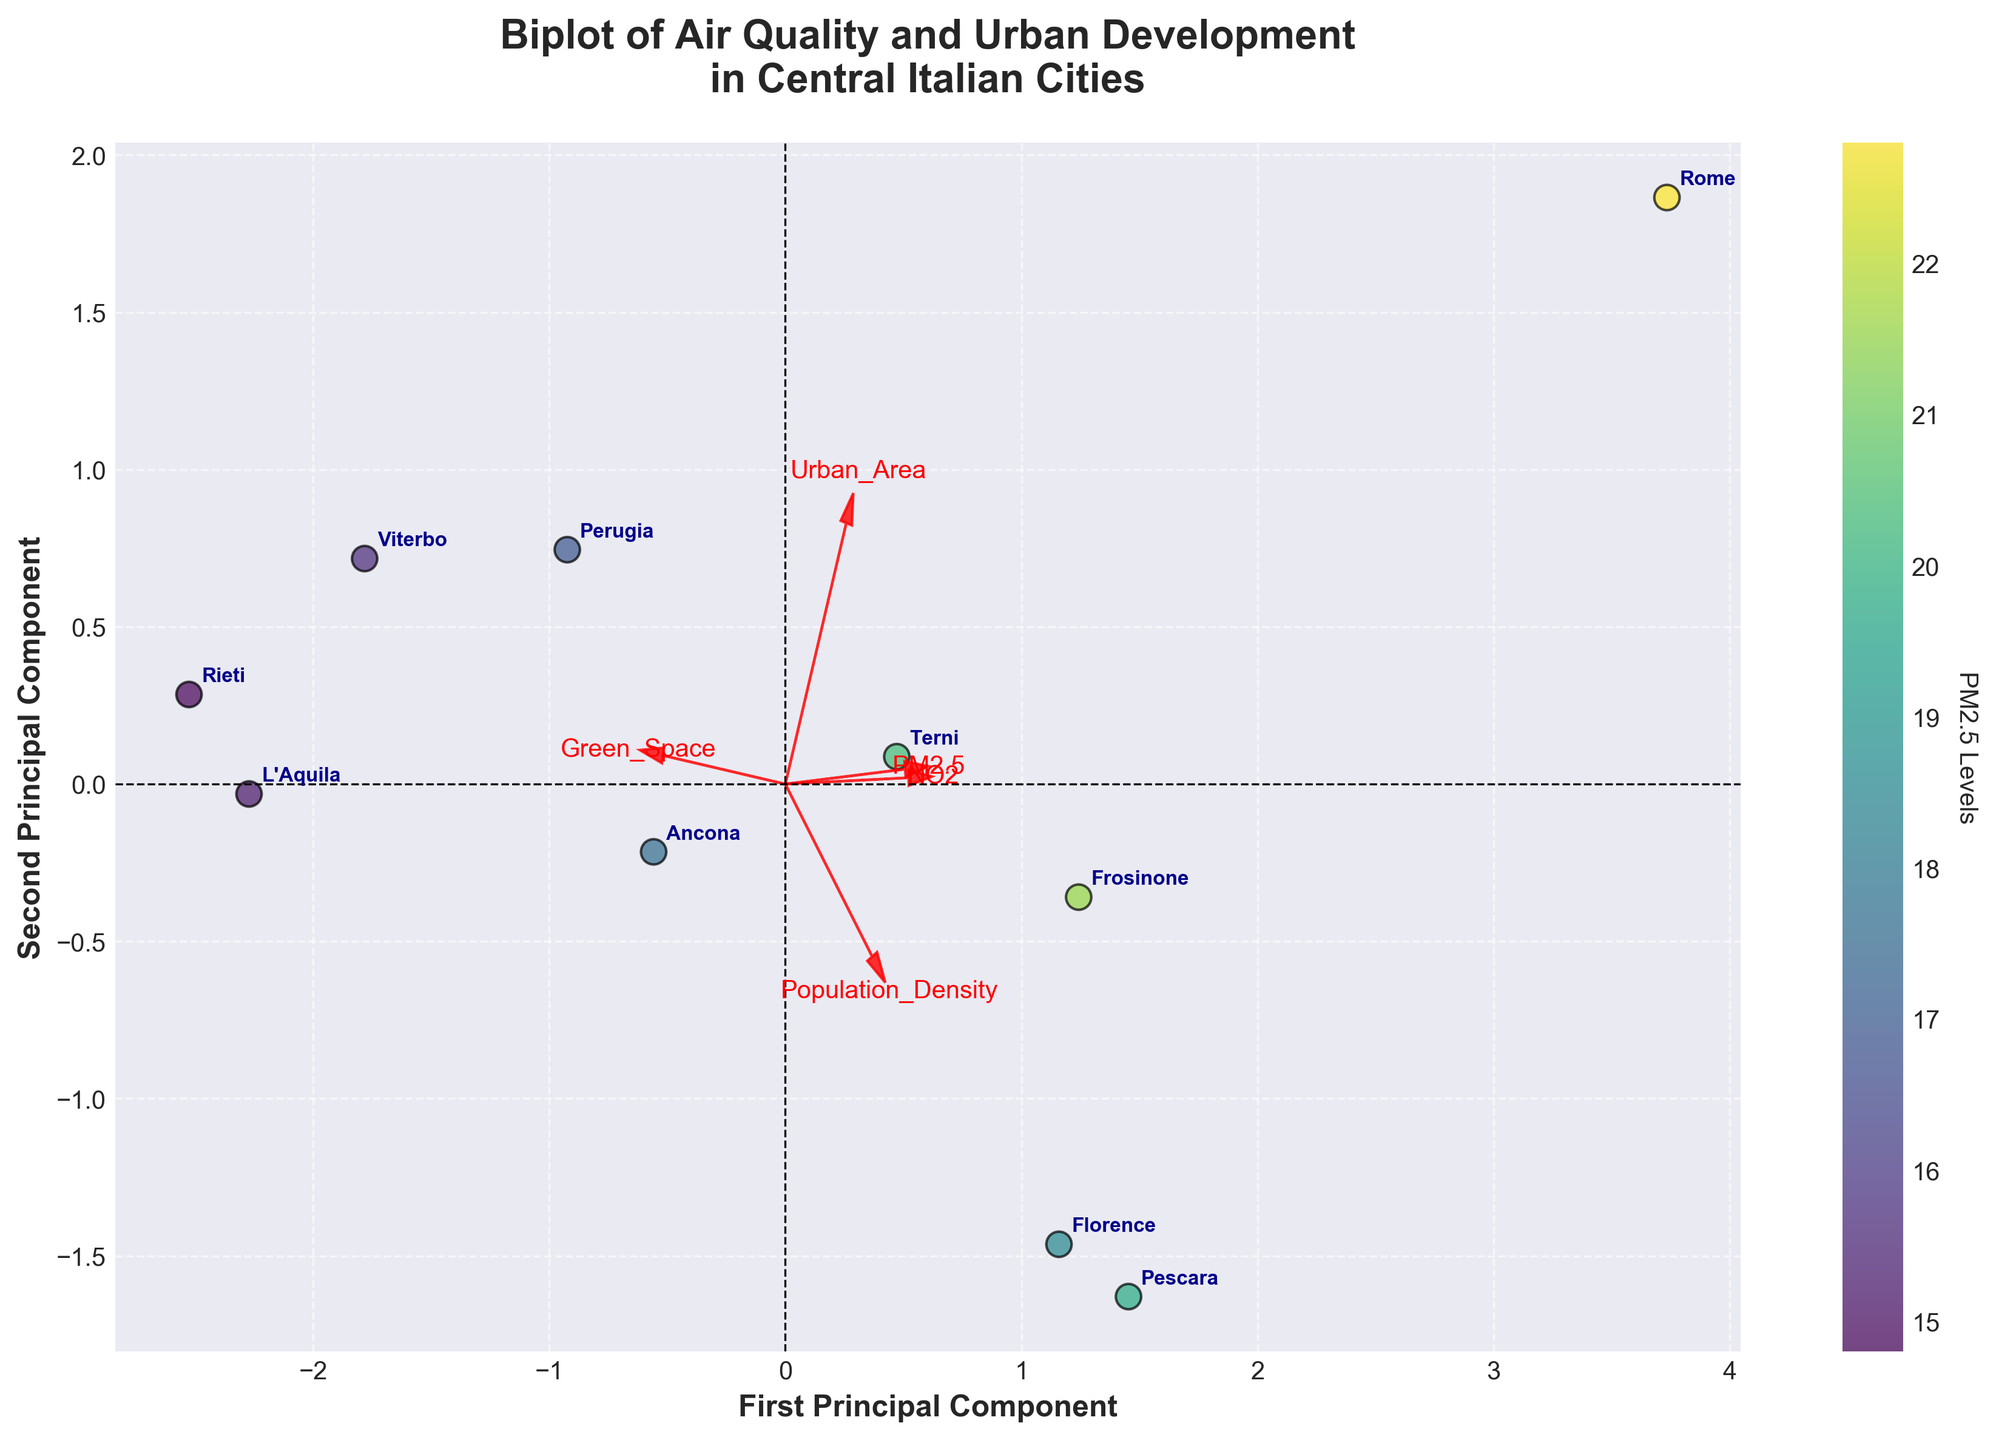Which city has the highest PM2.5 levels based on the biplot? The biplot shows data points colored by PM2.5 levels. By looking for the darkest shade (corresponding to the highest level of PM2.5), we can identify the city.
Answer: Rome Which city is associated with the highest value along the first principal component? The city with the farthest reach to the right along the x-axis of the biplot represents the highest value along the first principal component.
Answer: Rome Which parameter shows the longest feature vector on the biplot? Feature vectors are the red arrows in the biplot. The parameter with the longest arrow represents the parameter with the highest variance along the principal components.
Answer: Urban_Area How do L'Aquila and Frosinone compare in terms of PM2.5 levels? By looking at the color gradient of the data points for L'Aquila and Frosinone, we can compare their shades, which indicate PM2.5 levels.
Answer: L'Aquila has lower PM2.5 levels than Frosinone Which city has the lowest NO2 levels according to the biplot? By examining the scatter plot and observing the data points corresponding to NO2 along the corresponding feature vector, we can identify the city with the lowest value.
Answer: Rieti What direction does the 'Green_Space' vector point, and what does it imply? The direction of the 'Green_Space' vector can be observed in the biplot. It indicates the correlation of green space to the two principal components.
Answer: It points up and to the right, implying a positive correlation with both principal components If the 'Population_Density' vector is pointing in a certain direction, which city is furthest along its axis? By following the direction of the 'Population_Density' vector and finding the data point furthest along this vector, we can identify the city.
Answer: Pescara Which city lies closest to the origin of the biplot? The city located closest to the point (0,0) on the biplot is the one with values most similar to the mean of all parameters after standardization.
Answer: Viterbo Compare Ancona and Terni in terms of their positions along the second principal component. By observing their locations along the y-axis, we can see which city is positioned higher or lower.
Answer: Ancona is higher along the second principal component than Terni What connection can you draw between 'Urban_Area' and the first principal component? The direction and length of the 'Urban_Area' vector relative to the first principal component indicate a strong positive correlation.
Answer: Strong positive correlation 